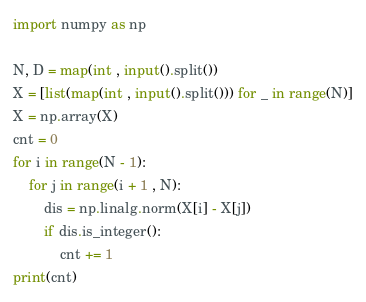<code> <loc_0><loc_0><loc_500><loc_500><_Python_>import numpy as np

N, D = map(int , input().split())
X = [list(map(int , input().split())) for _ in range(N)]
X = np.array(X)
cnt = 0
for i in range(N - 1):
    for j in range(i + 1 , N):
        dis = np.linalg.norm(X[i] - X[j])
        if dis.is_integer():
            cnt += 1
print(cnt)</code> 